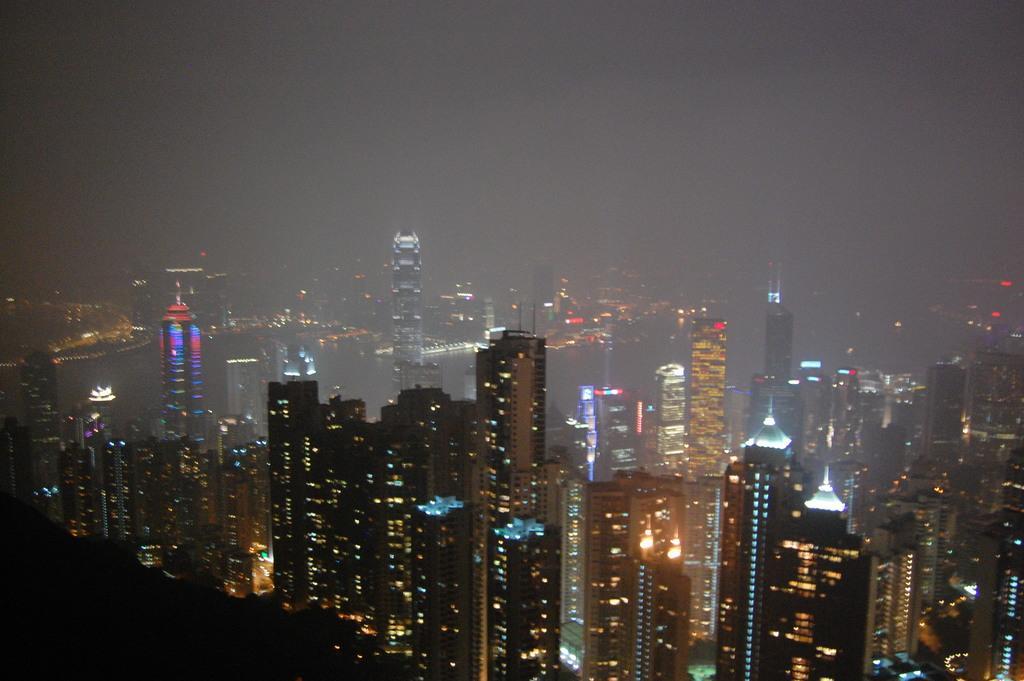Could you give a brief overview of what you see in this image? In this image there are buildings having lights. Top of the image there is sky. 